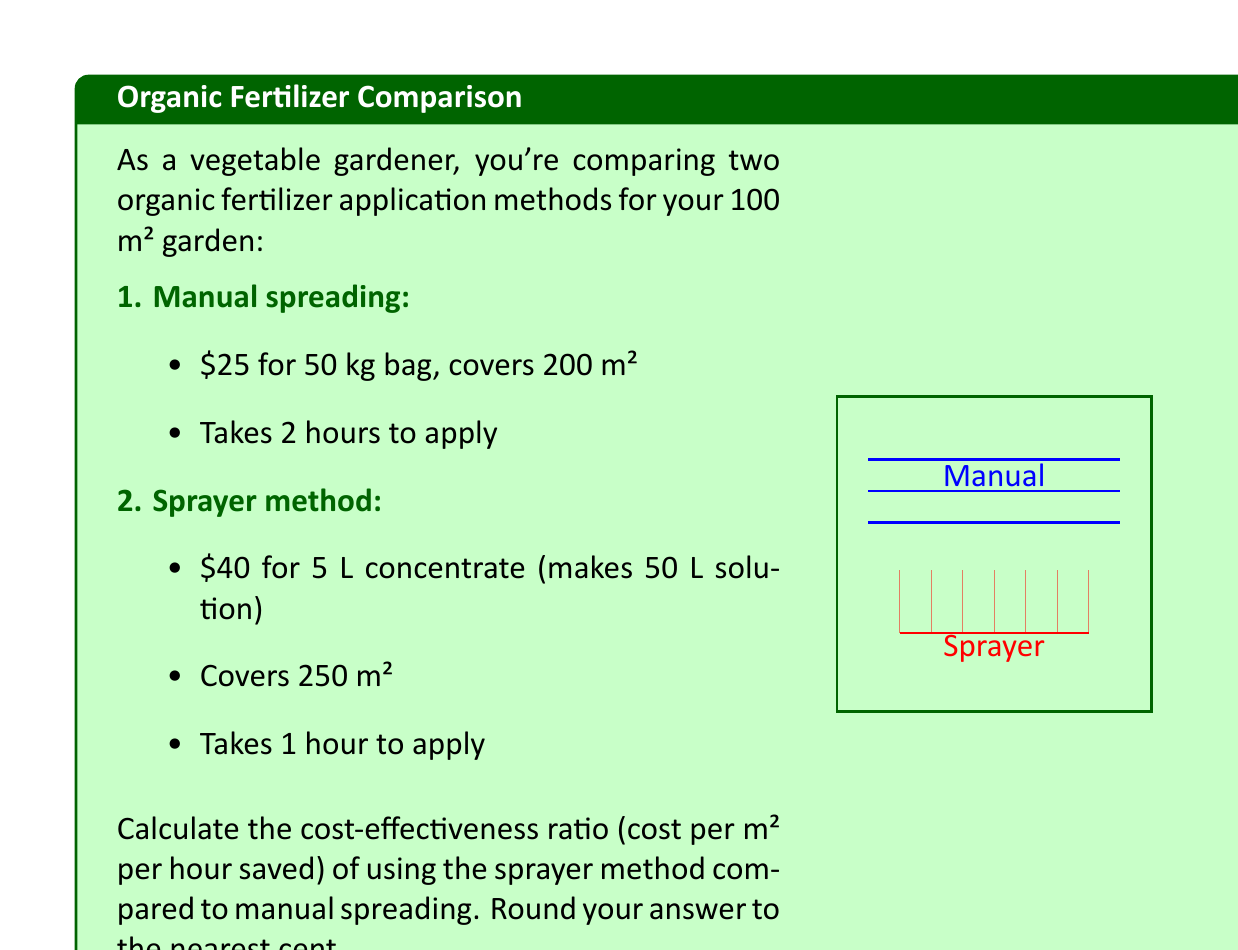Teach me how to tackle this problem. Let's approach this step-by-step:

1) First, calculate the cost per m² for each method:

   Manual: $\frac{\$25}{200 \text{ m}²} = \$0.125 \text{ per m}²$
   Sprayer: $\frac{\$40}{250 \text{ m}²} = \$0.16 \text{ per m}²$

2) For a 100 m² garden:
   
   Manual cost: $100 \text{ m}² \times \$0.125 \text{ per m}² = \$12.50$
   Sprayer cost: $100 \text{ m}² \times \$0.16 \text{ per m}² = \$16.00$

3) Time taken for 100 m²:
   
   Manual: $\frac{2 \text{ hours}}{200 \text{ m}²} \times 100 \text{ m}² = 1 \text{ hour}$
   Sprayer: $\frac{1 \text{ hour}}{250 \text{ m}²} \times 100 \text{ m}² = 0.4 \text{ hours}$

4) Time saved by using sprayer:
   
   $1 \text{ hour} - 0.4 \text{ hours} = 0.6 \text{ hours}$

5) Additional cost of using sprayer:
   
   $\$16.00 - \$12.50 = \$3.50$

6) Cost-effectiveness ratio:

   $\frac{\text{Additional cost}}{\text{Area} \times \text{Time saved}} = \frac{\$3.50}{100 \text{ m}² \times 0.6 \text{ hours}} = \frac{\$3.50}{60 \text{ m}²\cdot\text{hours}} = \$0.0583 \text{ per m}²\text{ per hour saved}$

7) Rounding to the nearest cent:

   $\$0.06 \text{ per m}²\text{ per hour saved}$
Answer: $0.06 \text{ per m}²\text{ per hour saved} 